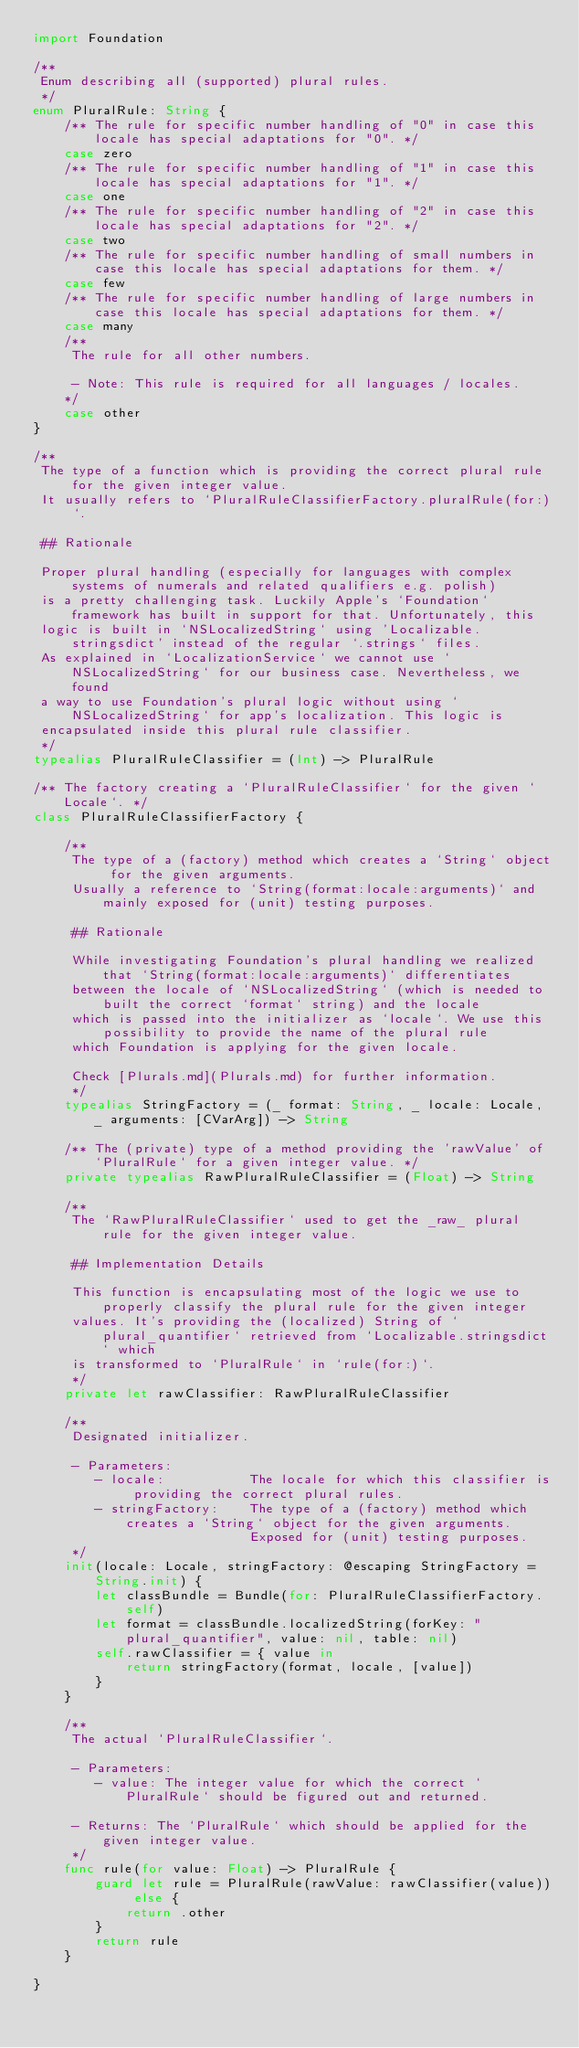Convert code to text. <code><loc_0><loc_0><loc_500><loc_500><_Swift_>import Foundation

/**
 Enum describing all (supported) plural rules.
 */
enum PluralRule: String {
    /** The rule for specific number handling of "0" in case this locale has special adaptations for "0". */
    case zero
    /** The rule for specific number handling of "1" in case this locale has special adaptations for "1". */
    case one
    /** The rule for specific number handling of "2" in case this locale has special adaptations for "2". */
    case two
    /** The rule for specific number handling of small numbers in case this locale has special adaptations for them. */
    case few
    /** The rule for specific number handling of large numbers in case this locale has special adaptations for them. */
    case many
    /**
     The rule for all other numbers.

     - Note: This rule is required for all languages / locales.
    */
    case other
}

/**
 The type of a function which is providing the correct plural rule for the given integer value.
 It usually refers to `PluralRuleClassifierFactory.pluralRule(for:)`.

 ## Rationale

 Proper plural handling (especially for languages with complex systems of numerals and related qualifiers e.g. polish)
 is a pretty challenging task. Luckily Apple's `Foundation` framework has built in support for that. Unfortunately, this
 logic is built in `NSLocalizedString` using 'Localizable.stringsdict' instead of the regular `.strings` files.
 As explained in `LocalizationService` we cannot use `NSLocalizedString` for our business case. Nevertheless, we found
 a way to use Foundation's plural logic without using `NSLocalizedString` for app's localization. This logic is
 encapsulated inside this plural rule classifier.
 */
typealias PluralRuleClassifier = (Int) -> PluralRule

/** The factory creating a `PluralRuleClassifier` for the given `Locale`. */
class PluralRuleClassifierFactory {

    /**
     The type of a (factory) method which creates a `String` object for the given arguments.
     Usually a reference to `String(format:locale:arguments)` and mainly exposed for (unit) testing purposes.

     ## Rationale

     While investigating Foundation's plural handling we realized that `String(format:locale:arguments)` differentiates
     between the locale of `NSLocalizedString` (which is needed to built the correct `format` string) and the locale
     which is passed into the initializer as `locale`. We use this possibility to provide the name of the plural rule
     which Foundation is applying for the given locale.

     Check [Plurals.md](Plurals.md) for further information.
     */
    typealias StringFactory = (_ format: String, _ locale: Locale, _ arguments: [CVarArg]) -> String

    /** The (private) type of a method providing the 'rawValue' of `PluralRule` for a given integer value. */
    private typealias RawPluralRuleClassifier = (Float) -> String

    /**
     The `RawPluralRuleClassifier` used to get the _raw_ plural rule for the given integer value.

     ## Implementation Details

     This function is encapsulating most of the logic we use to properly classify the plural rule for the given integer
     values. It's providing the (localized) String of `plural_quantifier` retrieved from `Localizable.stringsdict` which
     is transformed to `PluralRule` in `rule(for:)`.
     */
    private let rawClassifier: RawPluralRuleClassifier

    /**
     Designated initializer.

     - Parameters:
        - locale:           The locale for which this classifier is providing the correct plural rules.
        - stringFactory:    The type of a (factory) method which creates a `String` object for the given arguments.
                            Exposed for (unit) testing purposes.
     */
    init(locale: Locale, stringFactory: @escaping StringFactory = String.init) {
        let classBundle = Bundle(for: PluralRuleClassifierFactory.self)
        let format = classBundle.localizedString(forKey: "plural_quantifier", value: nil, table: nil)
        self.rawClassifier = { value in
            return stringFactory(format, locale, [value])
        }
    }

    /**
     The actual `PluralRuleClassifier`.

     - Parameters:
        - value: The integer value for which the correct `PluralRule` should be figured out and returned.

     - Returns: The `PluralRule` which should be applied for the given integer value.
     */
    func rule(for value: Float) -> PluralRule {
        guard let rule = PluralRule(rawValue: rawClassifier(value)) else {
            return .other
        }
        return rule
    }

}
</code> 